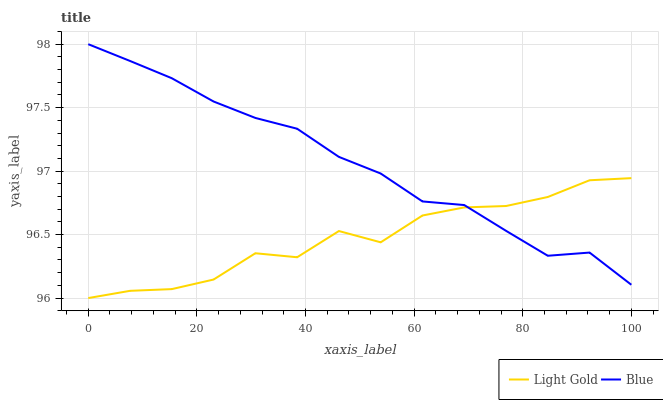Does Light Gold have the minimum area under the curve?
Answer yes or no. Yes. Does Blue have the maximum area under the curve?
Answer yes or no. Yes. Does Light Gold have the maximum area under the curve?
Answer yes or no. No. Is Blue the smoothest?
Answer yes or no. Yes. Is Light Gold the roughest?
Answer yes or no. Yes. Is Light Gold the smoothest?
Answer yes or no. No. Does Light Gold have the lowest value?
Answer yes or no. Yes. Does Blue have the highest value?
Answer yes or no. Yes. Does Light Gold have the highest value?
Answer yes or no. No. Does Light Gold intersect Blue?
Answer yes or no. Yes. Is Light Gold less than Blue?
Answer yes or no. No. Is Light Gold greater than Blue?
Answer yes or no. No. 